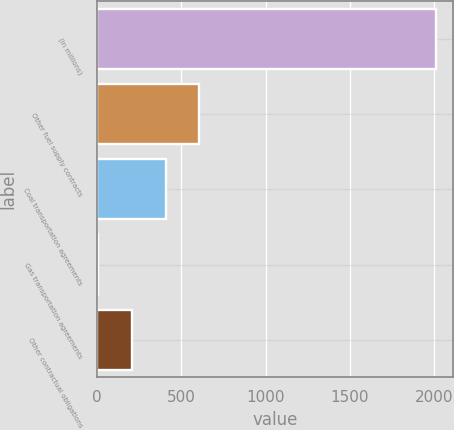<chart> <loc_0><loc_0><loc_500><loc_500><bar_chart><fcel>(in millions)<fcel>Other fuel supply contracts<fcel>Coal transportation agreements<fcel>Gas transportation agreements<fcel>Other contractual obligations<nl><fcel>2012<fcel>608.5<fcel>408<fcel>7<fcel>207.5<nl></chart> 